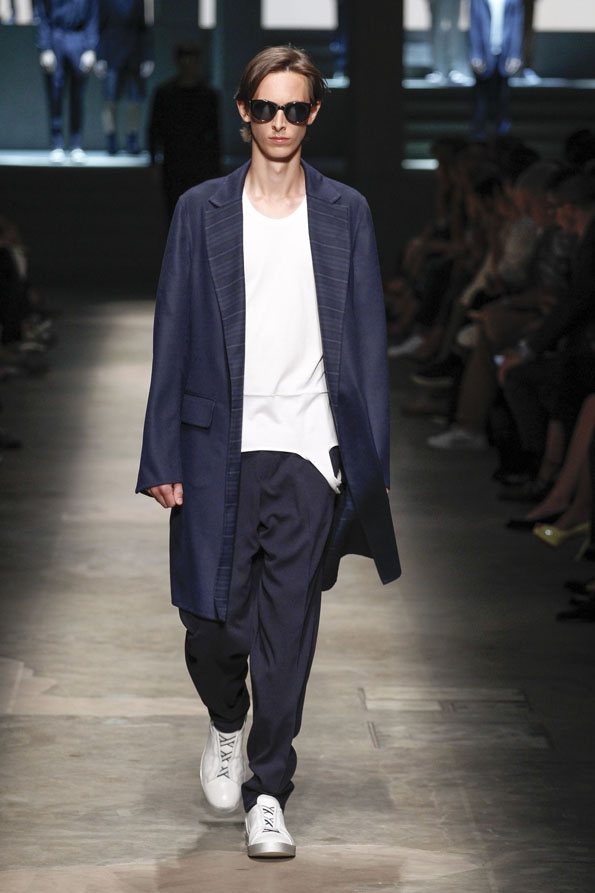Imagine this outfit in a different setting. How would it translate in a casual outdoor environment? In a casual outdoor environment, this outfit would convey a vibe of effortless chic. The oversized navy coat would provide a stylish layer for a cool day, while the loose trousers and simple white t-shirt maintain a comfortable, laid-back feel. Paired with white sneakers, the ensemble would be perfect for a leisurely stroll in the park or a casual coffee date. The versatility of the pieces allows for easy mixing and matching with other casual attire, making it adaptable to various outdoor settings. The dark sunglasses would add an extra touch of cool, protecting against the sun while keeping the look polished. 